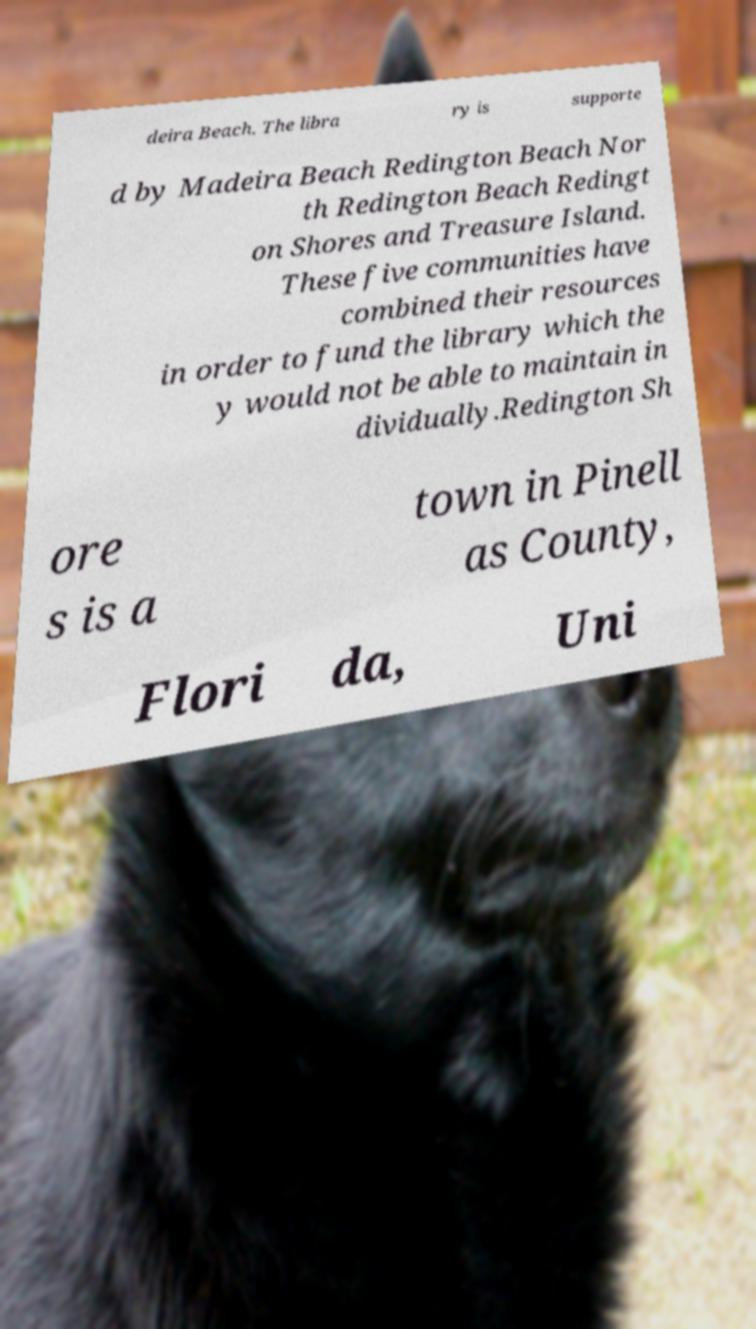I need the written content from this picture converted into text. Can you do that? deira Beach. The libra ry is supporte d by Madeira Beach Redington Beach Nor th Redington Beach Redingt on Shores and Treasure Island. These five communities have combined their resources in order to fund the library which the y would not be able to maintain in dividually.Redington Sh ore s is a town in Pinell as County, Flori da, Uni 